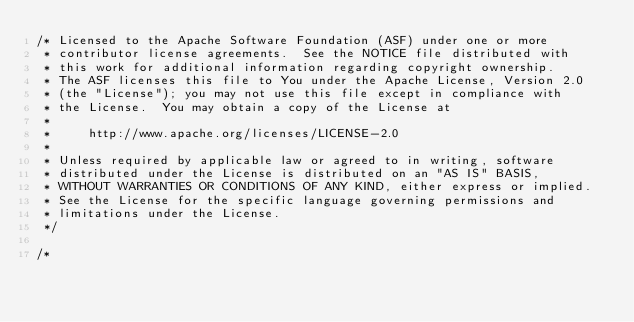<code> <loc_0><loc_0><loc_500><loc_500><_C_>/* Licensed to the Apache Software Foundation (ASF) under one or more
 * contributor license agreements.  See the NOTICE file distributed with
 * this work for additional information regarding copyright ownership.
 * The ASF licenses this file to You under the Apache License, Version 2.0
 * (the "License"); you may not use this file except in compliance with
 * the License.  You may obtain a copy of the License at
 *
 *     http://www.apache.org/licenses/LICENSE-2.0
 *
 * Unless required by applicable law or agreed to in writing, software
 * distributed under the License is distributed on an "AS IS" BASIS,
 * WITHOUT WARRANTIES OR CONDITIONS OF ANY KIND, either express or implied.
 * See the License for the specific language governing permissions and
 * limitations under the License.
 */

/*</code> 